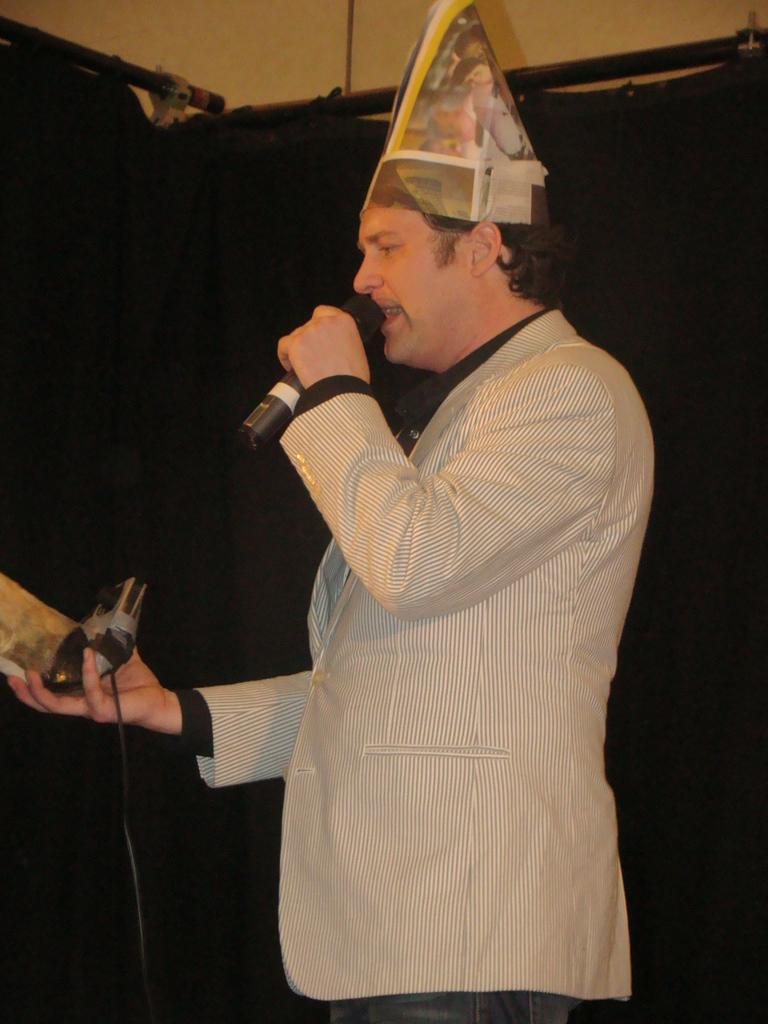Please provide a concise description of this image. In this image we can see there is a man standing holding a mike also there is a hat on his head. 